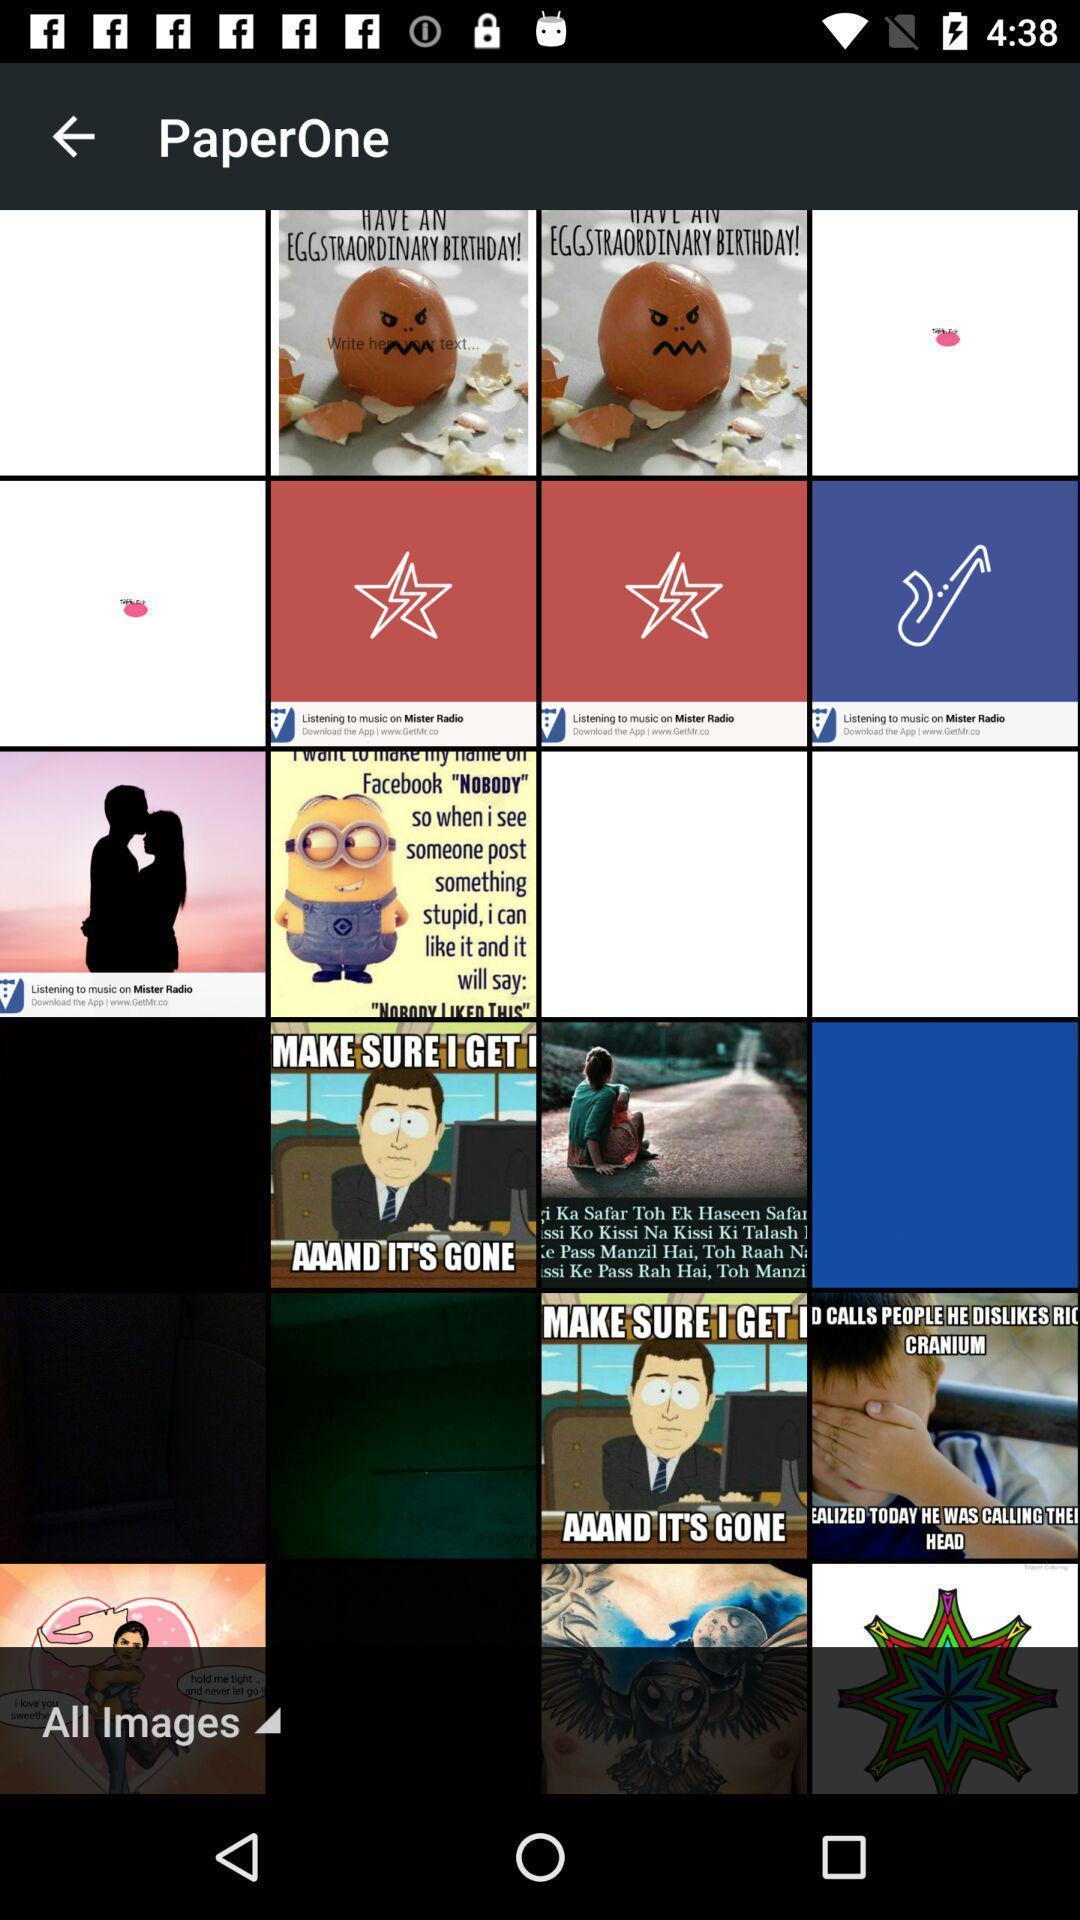Explain the elements present in this screenshot. Page displaying with multiple meme images. 